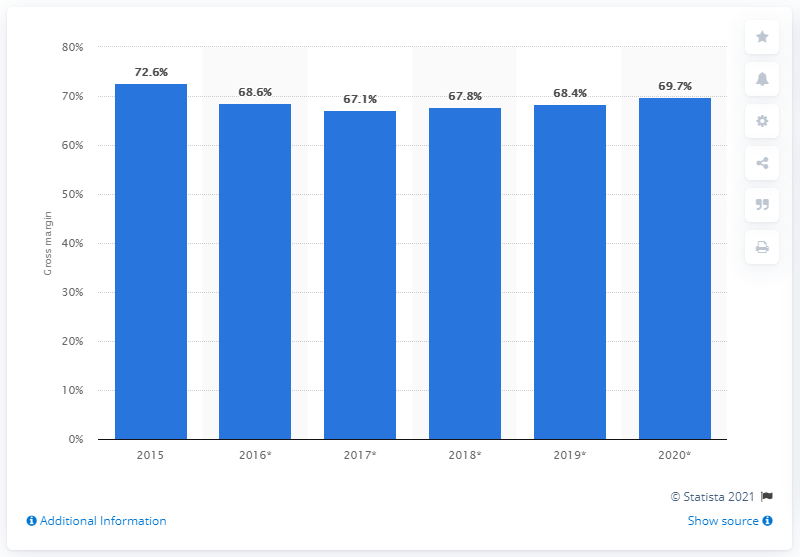Indicate a few pertinent items in this graphic. In 2020, the Lego Group's gross margin was 69.7%. 